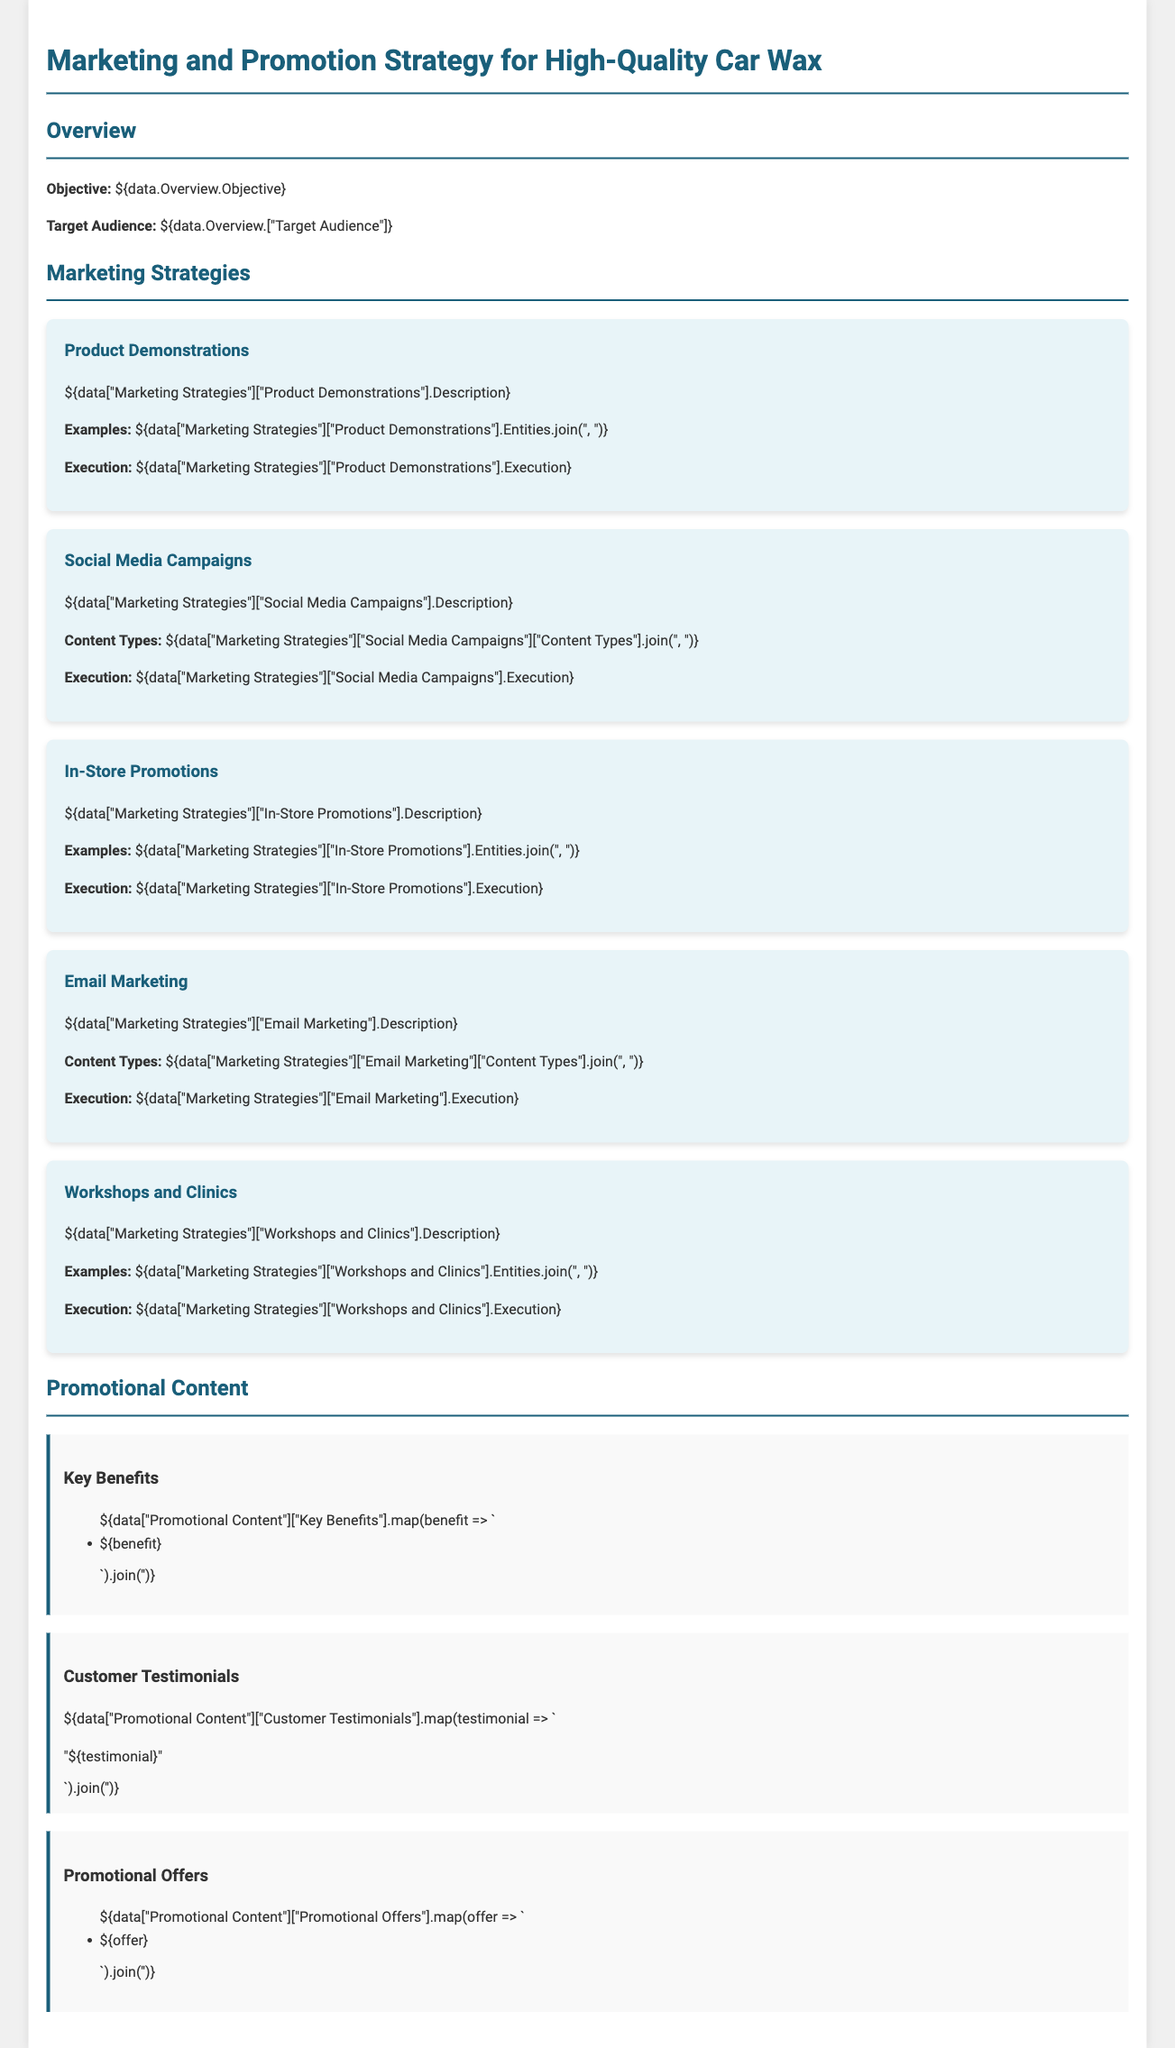What is the objective of the marketing strategy? The objective is stated in the overview section of the document.
Answer: Increase car wax sales Who is the target audience for the car wax? The target audience is specified in the overview section of the document.
Answer: Car enthusiasts What is one of the strategies listed for marketing? The document lists various marketing strategies, including product demonstrations, social media campaigns, etc.
Answer: Product demonstrations What types of content are included in the social media campaigns? The document specifies different content types that are utilized in the social media campaigns.
Answer: Videos, Images, Posts What evidence is provided to support the effectiveness of the car wax? The document includes a section showcasing customer feedback that supports its effectiveness.
Answer: Customer testimonials What is a benefit of using the high-quality car wax? The document lists several key benefits that highlight the advantages of the car wax.
Answer: Long-lasting protection How are email marketing strategies executed according to the document? The document explains the execution process for the email marketing strategy.
Answer: Sent monthly with updates What types of events are mentioned in the workshops and clinics section? This section presents types of interactions designed for customer engagement.
Answer: Car care workshops 